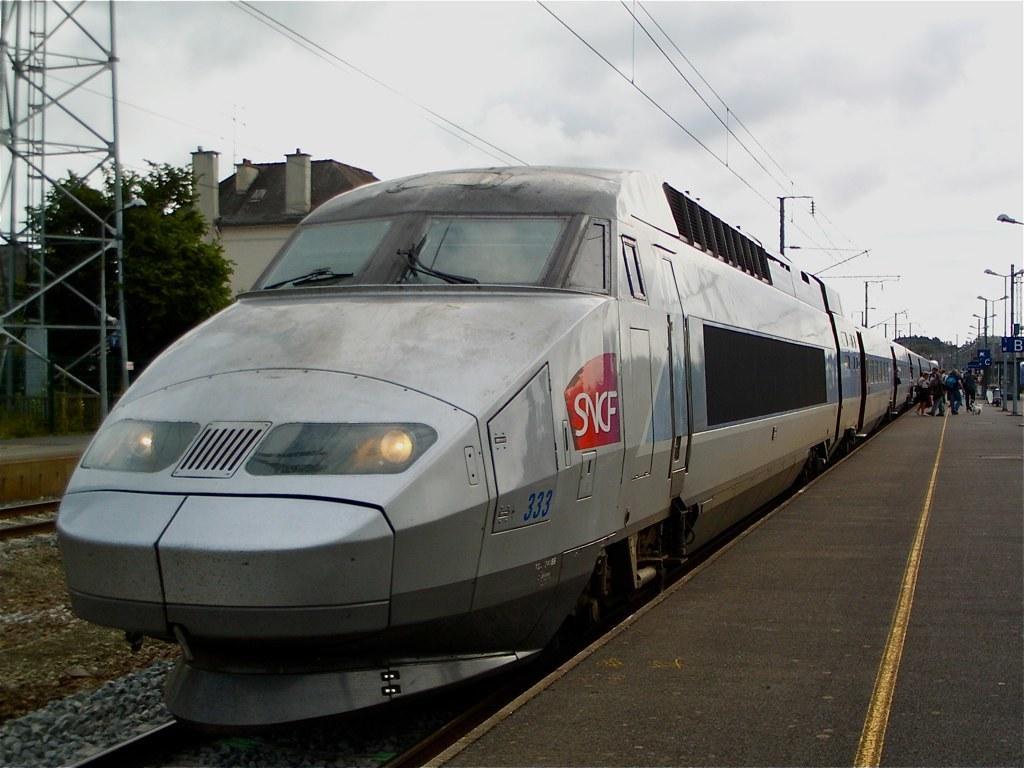In one or two sentences, can you explain what this image depicts? In this image there is a platform. light poles, boards, tree, train tracks, people, train, cloudy sky, buildings, rods and objects. Something is written on the train.   